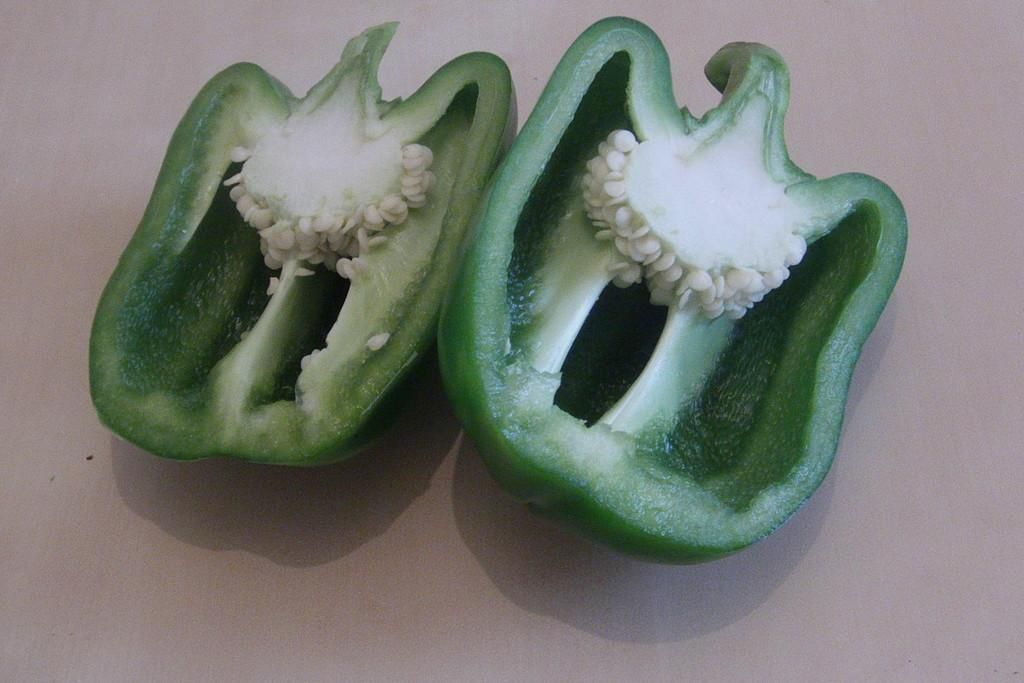What type of food is visible in the image? There are green pepper pieces in the image. What is the color of the surface on which the green pepper pieces are placed? The green pepper pieces are on a white surface. How does the friction between the green pepper pieces and the white surface affect their movement in the image? There is no indication of movement in the image, so it is not possible to determine how friction might affect it. 